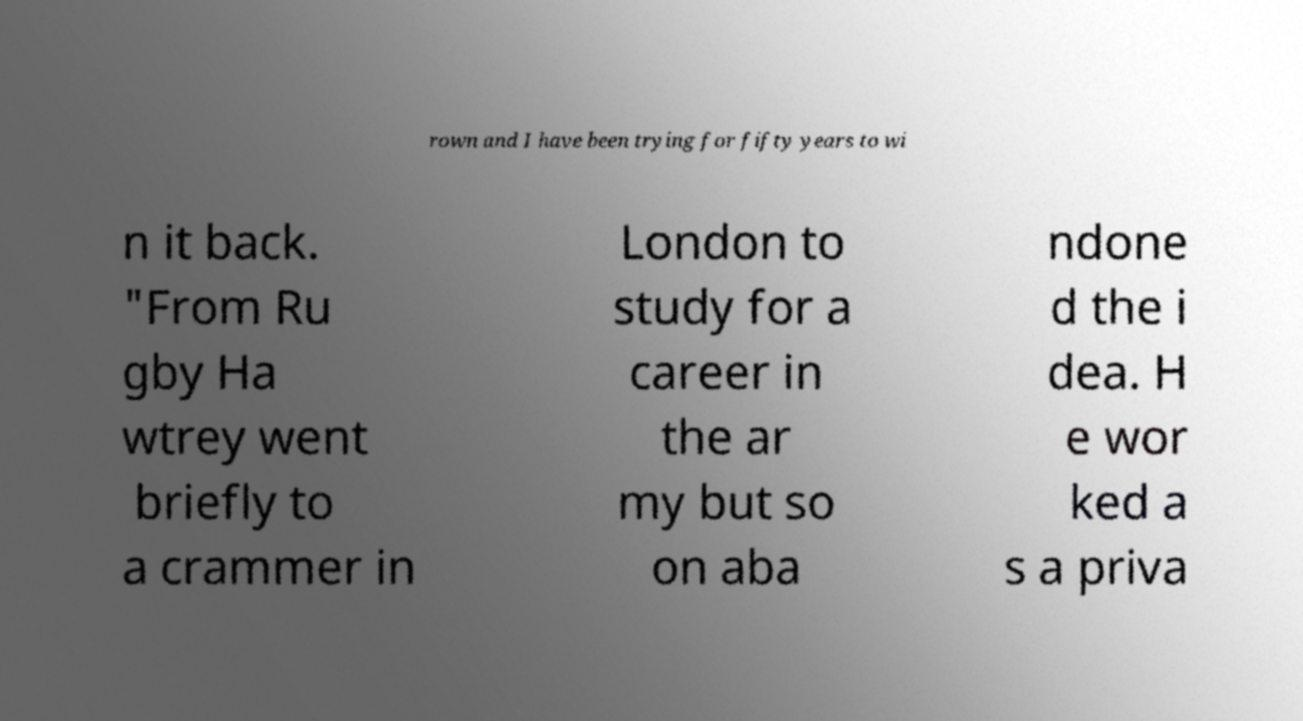Can you read and provide the text displayed in the image?This photo seems to have some interesting text. Can you extract and type it out for me? rown and I have been trying for fifty years to wi n it back. "From Ru gby Ha wtrey went briefly to a crammer in London to study for a career in the ar my but so on aba ndone d the i dea. H e wor ked a s a priva 